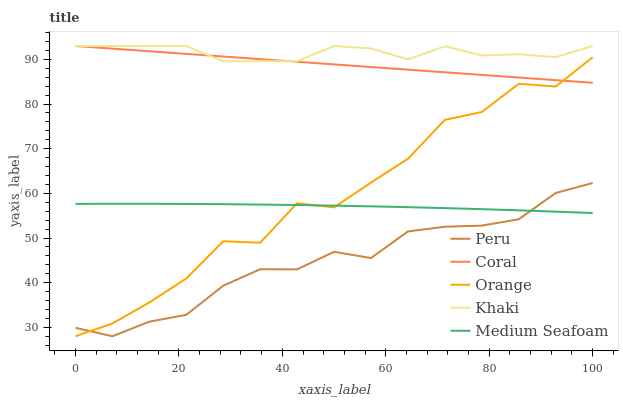Does Peru have the minimum area under the curve?
Answer yes or no. Yes. Does Khaki have the maximum area under the curve?
Answer yes or no. Yes. Does Coral have the minimum area under the curve?
Answer yes or no. No. Does Coral have the maximum area under the curve?
Answer yes or no. No. Is Coral the smoothest?
Answer yes or no. Yes. Is Orange the roughest?
Answer yes or no. Yes. Is Khaki the smoothest?
Answer yes or no. No. Is Khaki the roughest?
Answer yes or no. No. Does Orange have the lowest value?
Answer yes or no. Yes. Does Coral have the lowest value?
Answer yes or no. No. Does Khaki have the highest value?
Answer yes or no. Yes. Does Medium Seafoam have the highest value?
Answer yes or no. No. Is Peru less than Khaki?
Answer yes or no. Yes. Is Khaki greater than Peru?
Answer yes or no. Yes. Does Medium Seafoam intersect Peru?
Answer yes or no. Yes. Is Medium Seafoam less than Peru?
Answer yes or no. No. Is Medium Seafoam greater than Peru?
Answer yes or no. No. Does Peru intersect Khaki?
Answer yes or no. No. 